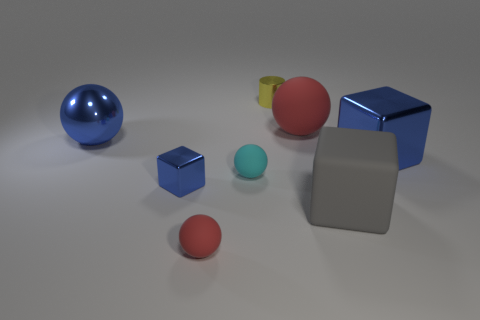What shape is the gray object that is made of the same material as the cyan thing?
Provide a short and direct response. Cube. Are there fewer big blue metallic cubes on the left side of the large red rubber sphere than small brown matte spheres?
Your answer should be compact. No. Does the cyan object have the same shape as the big red object?
Ensure brevity in your answer.  Yes. What number of rubber things are small yellow things or red things?
Provide a short and direct response. 2. Are there any rubber blocks that have the same size as the cyan rubber object?
Offer a terse response. No. There is a big metallic object that is the same color as the metal ball; what is its shape?
Provide a succinct answer. Cube. What number of matte spheres are the same size as the shiny ball?
Offer a very short reply. 1. There is a blue metallic cube that is to the right of the small yellow thing; is its size the same as the blue metallic block that is on the left side of the large red rubber thing?
Provide a succinct answer. No. How many objects are either big spheres or tiny rubber things that are on the left side of the tiny cyan sphere?
Give a very brief answer. 3. What is the color of the cylinder?
Provide a succinct answer. Yellow. 